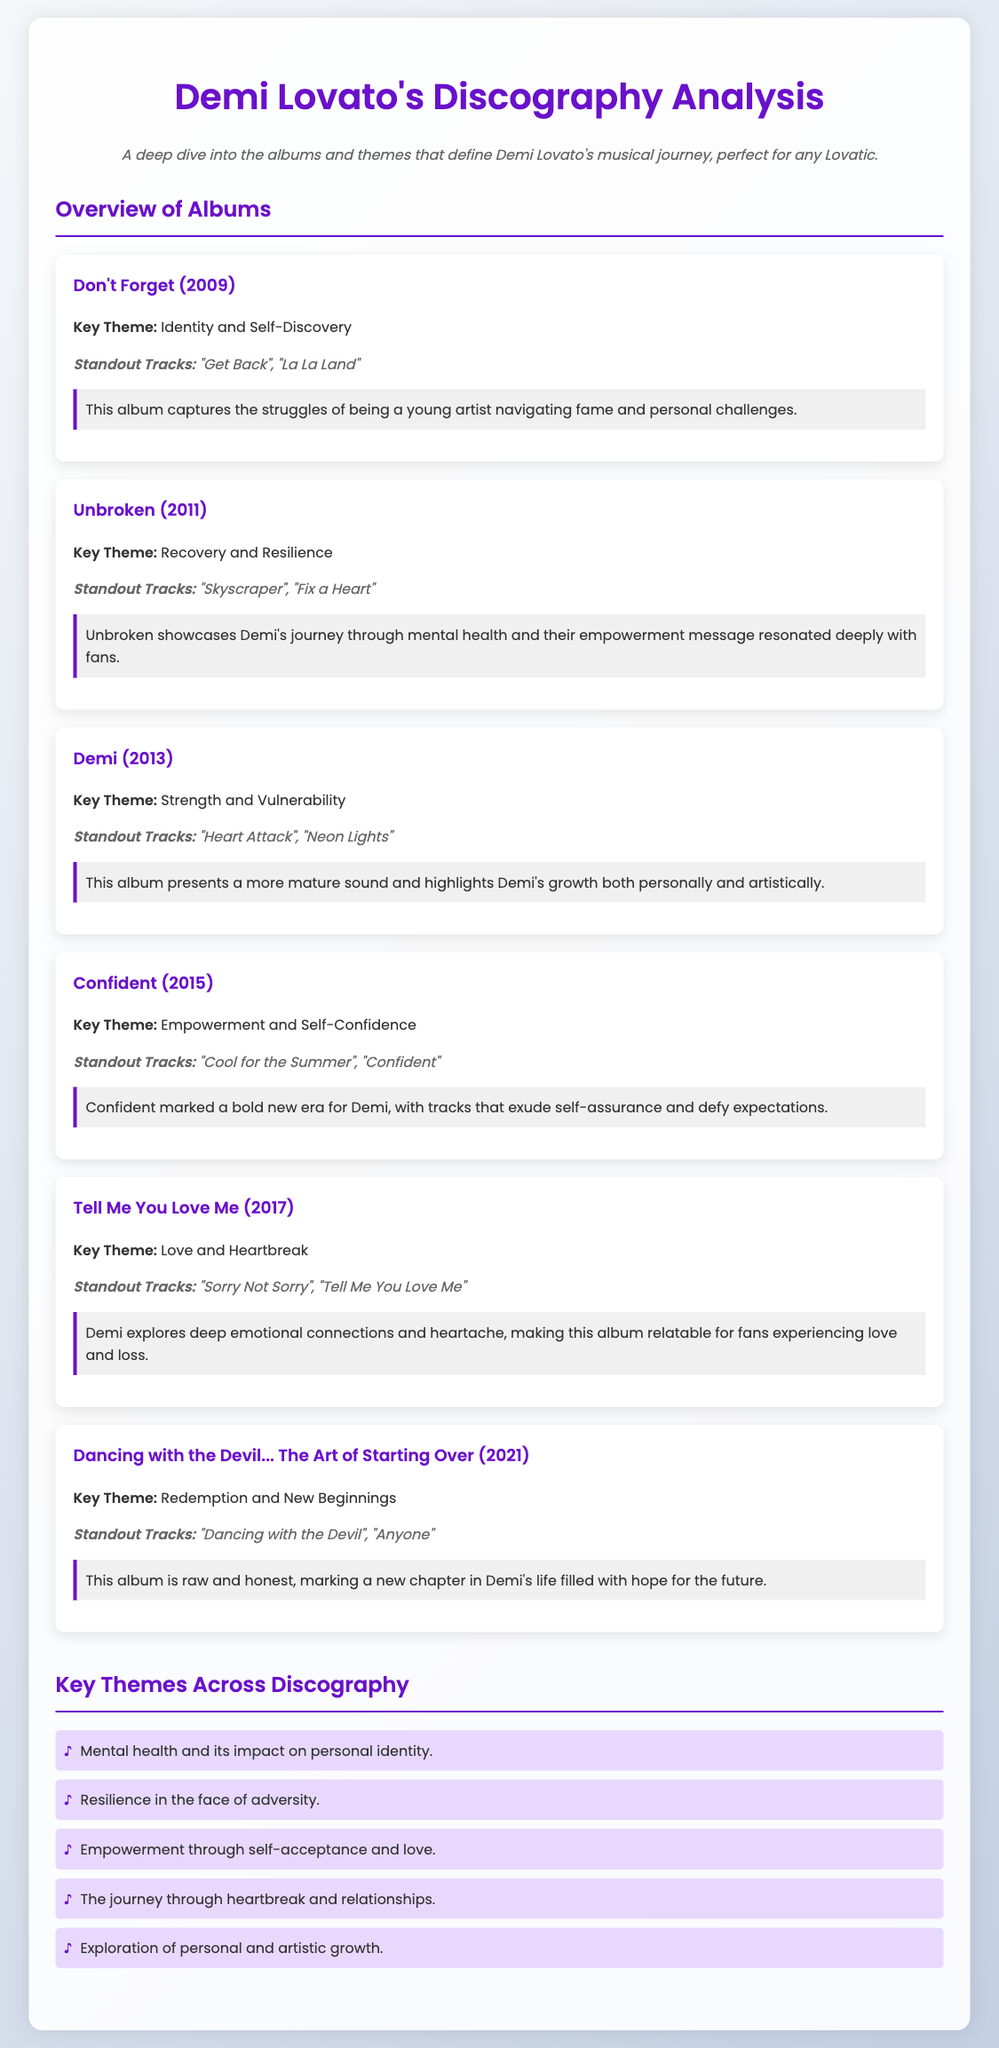What is the key theme of the album "Unbroken"? The key theme of "Unbroken" focuses on recovery and resilience as it addresses Demi's journey through mental health challenges.
Answer: Recovery and Resilience What standout track is associated with the album "Demi"? This album features "Heart Attack" as one of its standout tracks, showcasing Demi's powerful vocals and emotional depth.
Answer: Heart Attack How many albums are analyzed in the document? The document provides an analysis of a total of six albums from Demi Lovato's discography.
Answer: Six What emotion does the album "Tell Me You Love Me" primarily explore? The album dives into themes of love and heartbreak, reflecting on emotional connections and loss.
Answer: Love and Heartbreak Which album marked a bold new era with an emphasis on empowerment? "Confident" is the album that signifies a new direction in Demi's music, focusing on self-confidence and empowerment.
Answer: Confident What are the standout tracks from the album "Dancing with the Devil... The Art of Starting Over"? The standout tracks from this album include "Dancing with the Devil" and "Anyone," highlighting Demi's vulnerability.
Answer: Dancing with the Devil, Anyone What is a common key theme across Demi’s discography? A prevalent theme in Demi's music is mental health and its impact on personal identity, reflecting her experiences and struggles.
Answer: Mental health and its impact on personal identity What year was the album "Don't Forget" released? The album "Don't Forget" was released in the year 2009, marking the beginning of Demi's musical career.
Answer: 2009 